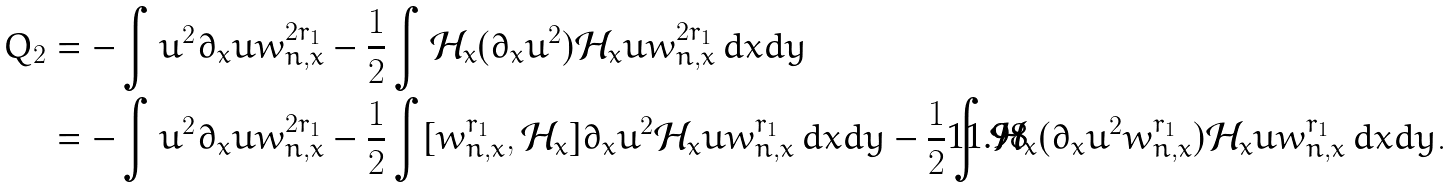<formula> <loc_0><loc_0><loc_500><loc_500>Q _ { 2 } & = - \int u ^ { 2 } \partial _ { x } u w _ { n , x } ^ { 2 r _ { 1 } } - \frac { 1 } { 2 } \int \mathcal { H } _ { x } ( \partial _ { x } u ^ { 2 } ) \mathcal { H } _ { x } u w _ { n , x } ^ { 2 r _ { 1 } } \, d x d y \\ & = - \int u ^ { 2 } \partial _ { x } u w _ { n , x } ^ { 2 r _ { 1 } } - \frac { 1 } { 2 } \int [ w _ { n , x } ^ { r _ { 1 } } , \mathcal { H } _ { x } ] \partial _ { x } u ^ { 2 } \mathcal { H } _ { x } u w _ { n , x } ^ { r _ { 1 } } \, d x d y - \frac { 1 } { 2 } \int \mathcal { H } _ { x } ( \partial _ { x } u ^ { 2 } w _ { n , x } ^ { r _ { 1 } } ) \mathcal { H } _ { x } u w _ { n , x } ^ { r _ { 1 } } \, d x d y .</formula> 